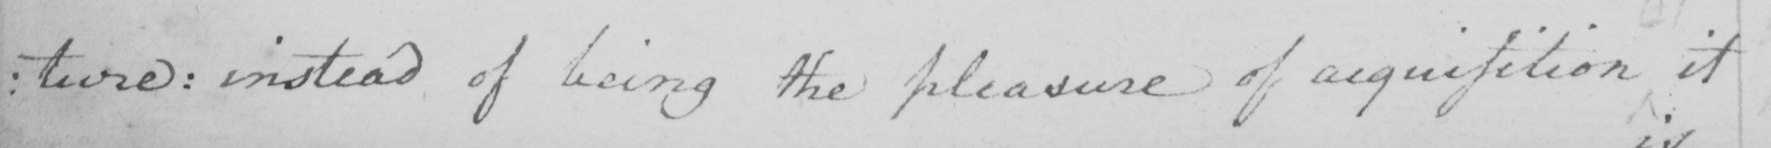Please transcribe the handwritten text in this image. : ture :  instead of being the pleasure of acquisition it 